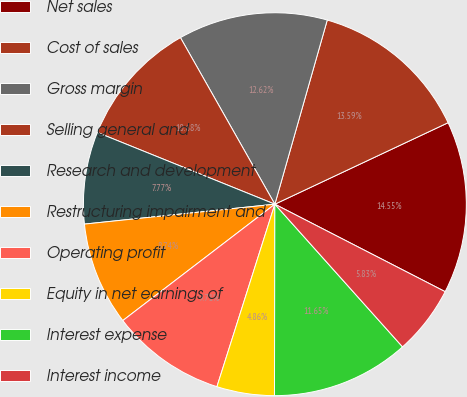Convert chart. <chart><loc_0><loc_0><loc_500><loc_500><pie_chart><fcel>Net sales<fcel>Cost of sales<fcel>Gross margin<fcel>Selling general and<fcel>Research and development<fcel>Restructuring impairment and<fcel>Operating profit<fcel>Equity in net earnings of<fcel>Interest expense<fcel>Interest income<nl><fcel>14.55%<fcel>13.59%<fcel>12.62%<fcel>10.68%<fcel>7.77%<fcel>8.74%<fcel>9.71%<fcel>4.86%<fcel>11.65%<fcel>5.83%<nl></chart> 